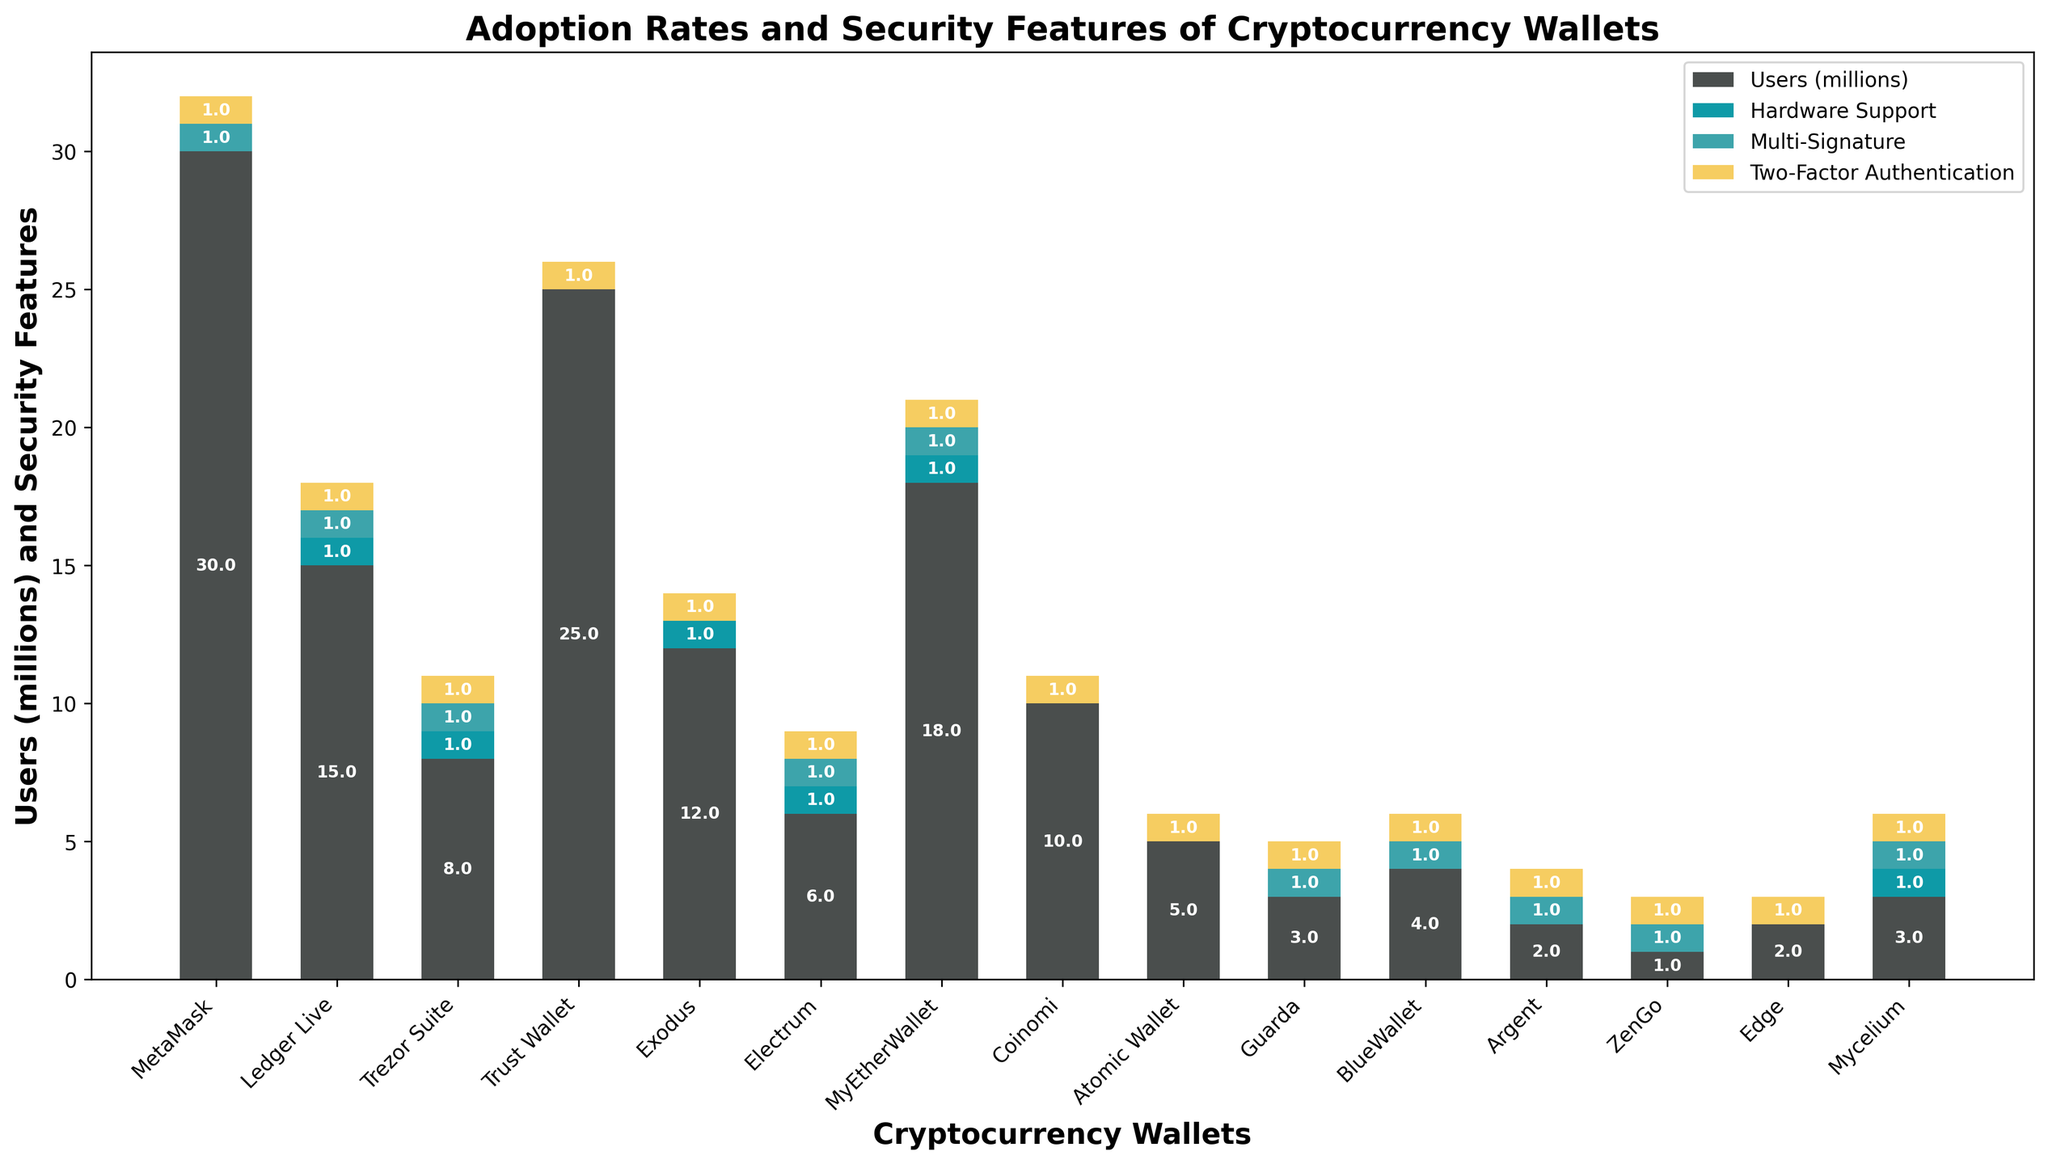What is the total number of users among wallets that support hardware? Sum the users of all wallets that have 'Yes' under Hardware Support: Ledger Live (15), Trezor Suite (8), Exodus (12), Electrum (6), MyEtherWallet (18), Mycelium (3). The sum is 15 + 8 + 12 + 6 + 18 + 3 = 62.
Answer: 62 Which wallet has the highest number of users? Identify the wallet with the tallest bar in the figure, which represents the highest number of users. MetaMask has 30 million users, which is the tallest bar.
Answer: MetaMask How many wallets do not support multi-signature? Count the bars where the segment for Multi-Signature (typically a specific color) is absent (i.e., height is zero). Those wallets are Trust Wallet, Exodus, Coinomi, Atomic Wallet, Edge. There are 5 wallets in total.
Answer: 5 What is the difference in user count between the wallet with the highest and lowest number of users? Subtract the smallest value of the bars from the largest value: MetaMask (30 million) - ZenGo (1 million) = 29 million.
Answer: 29 million How many wallets support both hardware and multi-signature features? Identify the bars that have segments representing both Hardware Support and Multi-Signature. Those wallets are Ledger Live, Trezor Suite, Electrum, MyEtherWallet, Mycelium. There are 5 wallets in total.
Answer: 5 What is the combined user count of wallets that support all three security features? Sum the users of all wallets that have 'Yes' under all three security columns. Those wallets are Ledger Live (15), Trezor Suite (8), Electrum (6), MyEtherWallet (18), Mycelium (3). The sum is 15 + 8 + 6 + 18 + 3 = 50.
Answer: 50 Which wallet without hardware support has the highest user count? Among wallets with 'No' under Hardware Support, determine which has the highest users. MetaMask, with 30 million users, has no hardware support and the highest user count among such wallets.
Answer: MetaMask What is the average user count for wallets that support two-factor authentication? Sum the users of wallets supporting two-factor authentication and divide by the number of those wallets. The wallets are MetaMask (30), Ledger Live (15), Trezor Suite (8), Trust Wallet (25), Exodus (12), Electrum (6), MyEtherWallet (18), Coinomi (10), Atomic Wallet (5), Guarda (3), BlueWallet (4), Argent (2), ZenGo (1), Edge (2), Mycelium (3). The sum is 144, and there are 15 wallets. The average is 144 / 15 = 9.6 million.
Answer: 9.6 million Which wallets have exactly three security features ('Yes') and what is their total user count? Identify the wallets with 'Yes' for all three security features and sum their users: Ledger Live (15), Trezor Suite (8), Electrum (6), MyEtherWallet (18), Mycelium (3). The total is 15 + 8 + 6 + 18 + 3 = 50.
Answer: Ledger Live, Trezor Suite, Electrum, MyEtherWallet, Mycelium; total 50 How many wallets do not support two-factor authentication? Count the wallets with 'No' under Two-Factor Authentication. Those wallets are Trust Wallet, Exodus, Coinomi, Atomic Wallet, Edge, Mycelium, making a total of 6 wallets.
Answer: 6 